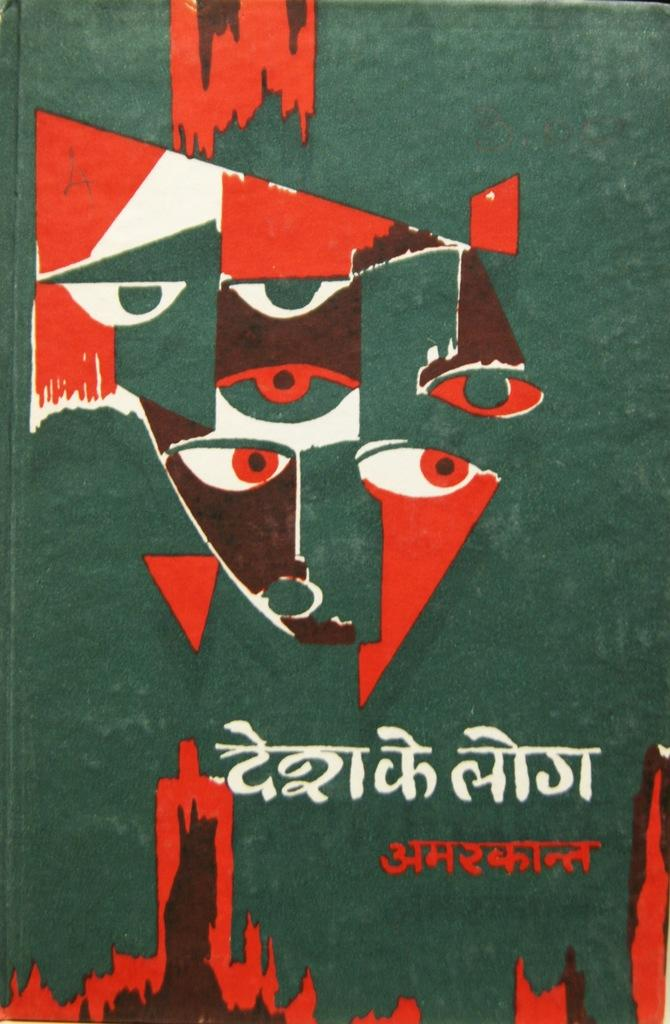What is the main subject of the image? The main subject of the image is the cover page of a book. Can you describe any text or writing on the cover page? Yes, there is text written at the bottom of the cover page. What type of alarm is depicted on the cover page of the book? There is no alarm depicted on the cover page of the book; it only features text at the bottom. How many thumbs are visible on the cover page of the book? There are no thumbs visible on the cover page of the book; it only features text at the bottom. 